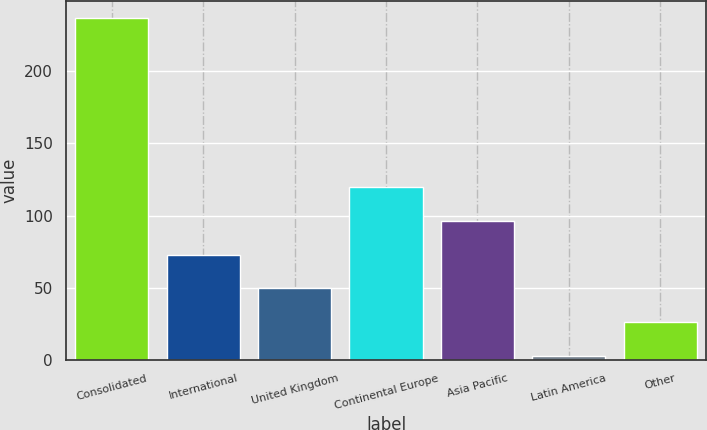<chart> <loc_0><loc_0><loc_500><loc_500><bar_chart><fcel>Consolidated<fcel>International<fcel>United Kingdom<fcel>Continental Europe<fcel>Asia Pacific<fcel>Latin America<fcel>Other<nl><fcel>236.6<fcel>73.01<fcel>49.64<fcel>119.75<fcel>96.38<fcel>2.9<fcel>26.27<nl></chart> 